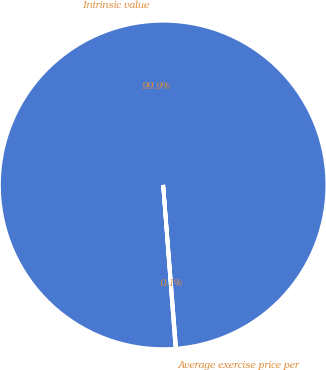<chart> <loc_0><loc_0><loc_500><loc_500><pie_chart><fcel>Intrinsic value<fcel>Average exercise price per<nl><fcel>99.94%<fcel>0.06%<nl></chart> 